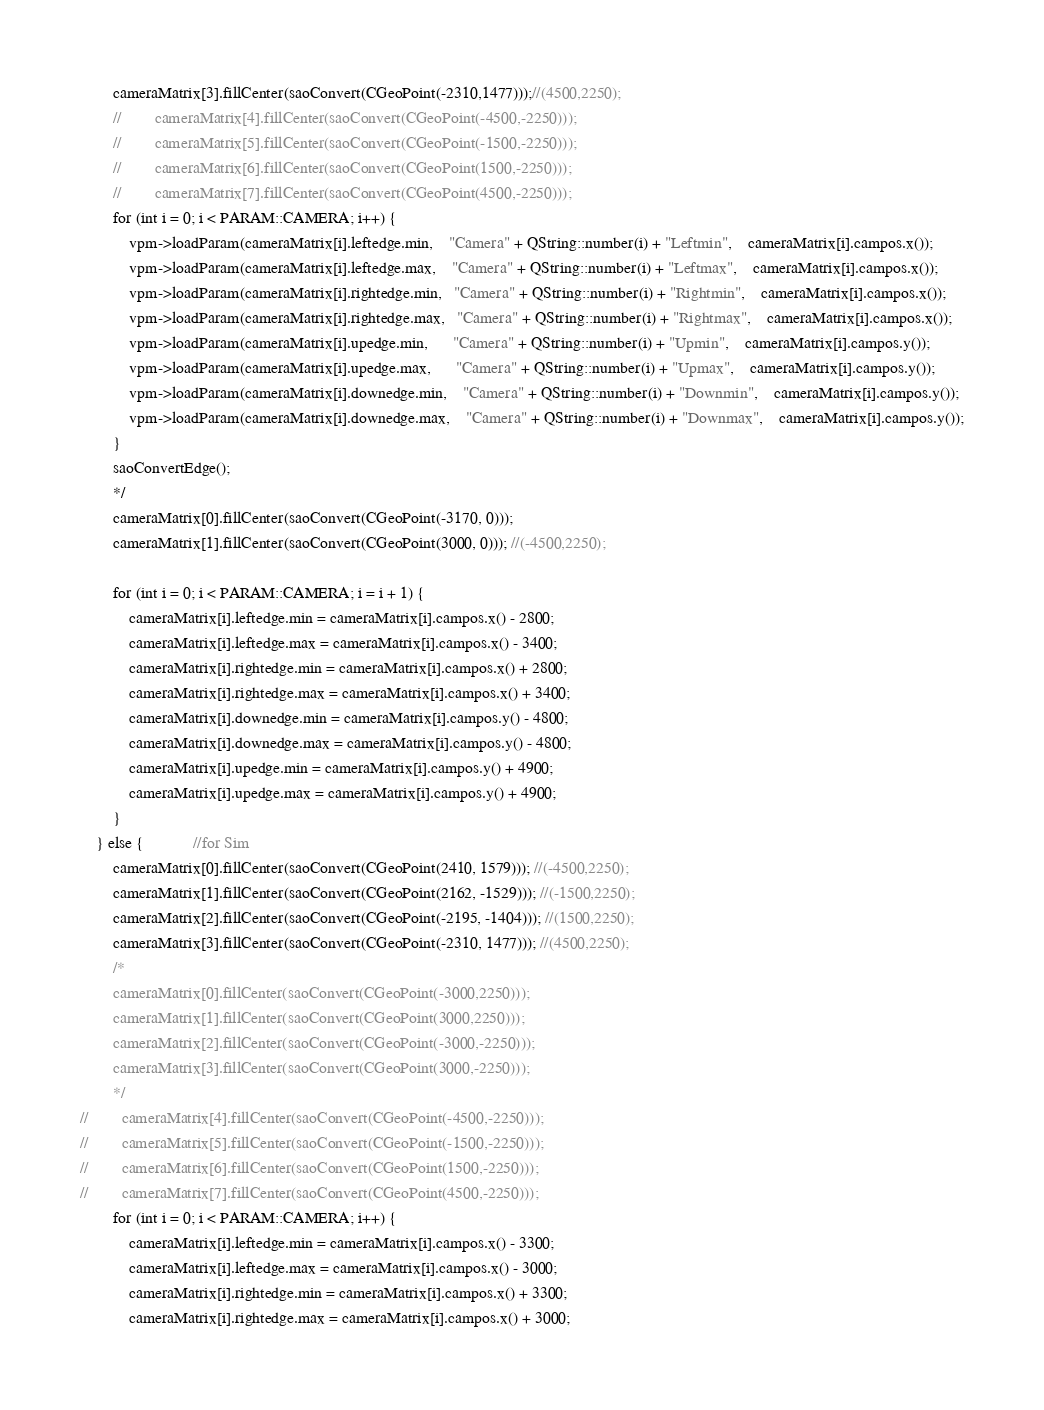Convert code to text. <code><loc_0><loc_0><loc_500><loc_500><_C++_>        cameraMatrix[3].fillCenter(saoConvert(CGeoPoint(-2310,1477)));//(4500,2250);
        //        cameraMatrix[4].fillCenter(saoConvert(CGeoPoint(-4500,-2250)));
        //        cameraMatrix[5].fillCenter(saoConvert(CGeoPoint(-1500,-2250)));
        //        cameraMatrix[6].fillCenter(saoConvert(CGeoPoint(1500,-2250)));
        //        cameraMatrix[7].fillCenter(saoConvert(CGeoPoint(4500,-2250)));
        for (int i = 0; i < PARAM::CAMERA; i++) {
            vpm->loadParam(cameraMatrix[i].leftedge.min,    "Camera" + QString::number(i) + "Leftmin",	cameraMatrix[i].campos.x());
            vpm->loadParam(cameraMatrix[i].leftedge.max,    "Camera" + QString::number(i) + "Leftmax",	cameraMatrix[i].campos.x());
            vpm->loadParam(cameraMatrix[i].rightedge.min,   "Camera" + QString::number(i) + "Rightmin",	cameraMatrix[i].campos.x());
            vpm->loadParam(cameraMatrix[i].rightedge.max,   "Camera" + QString::number(i) + "Rightmax",	cameraMatrix[i].campos.x());
            vpm->loadParam(cameraMatrix[i].upedge.min,      "Camera" + QString::number(i) + "Upmin",	cameraMatrix[i].campos.y());
            vpm->loadParam(cameraMatrix[i].upedge.max,      "Camera" + QString::number(i) + "Upmax",	cameraMatrix[i].campos.y());
            vpm->loadParam(cameraMatrix[i].downedge.min,    "Camera" + QString::number(i) + "Downmin",	cameraMatrix[i].campos.y());
            vpm->loadParam(cameraMatrix[i].downedge.max,    "Camera" + QString::number(i) + "Downmax",	cameraMatrix[i].campos.y());
        }
        saoConvertEdge();
        */
        cameraMatrix[0].fillCenter(saoConvert(CGeoPoint(-3170, 0)));
        cameraMatrix[1].fillCenter(saoConvert(CGeoPoint(3000, 0))); //(-4500,2250);

        for (int i = 0; i < PARAM::CAMERA; i = i + 1) {
            cameraMatrix[i].leftedge.min = cameraMatrix[i].campos.x() - 2800;
            cameraMatrix[i].leftedge.max = cameraMatrix[i].campos.x() - 3400;
            cameraMatrix[i].rightedge.min = cameraMatrix[i].campos.x() + 2800;
            cameraMatrix[i].rightedge.max = cameraMatrix[i].campos.x() + 3400;
            cameraMatrix[i].downedge.min = cameraMatrix[i].campos.y() - 4800;
            cameraMatrix[i].downedge.max = cameraMatrix[i].campos.y() - 4800;
            cameraMatrix[i].upedge.min = cameraMatrix[i].campos.y() + 4900;
            cameraMatrix[i].upedge.max = cameraMatrix[i].campos.y() + 4900;
        }
    } else {            //for Sim
        cameraMatrix[0].fillCenter(saoConvert(CGeoPoint(2410, 1579))); //(-4500,2250);
        cameraMatrix[1].fillCenter(saoConvert(CGeoPoint(2162, -1529))); //(-1500,2250);
        cameraMatrix[2].fillCenter(saoConvert(CGeoPoint(-2195, -1404))); //(1500,2250);
        cameraMatrix[3].fillCenter(saoConvert(CGeoPoint(-2310, 1477))); //(4500,2250);
        /*
        cameraMatrix[0].fillCenter(saoConvert(CGeoPoint(-3000,2250)));
        cameraMatrix[1].fillCenter(saoConvert(CGeoPoint(3000,2250)));
        cameraMatrix[2].fillCenter(saoConvert(CGeoPoint(-3000,-2250)));
        cameraMatrix[3].fillCenter(saoConvert(CGeoPoint(3000,-2250)));
        */
//        cameraMatrix[4].fillCenter(saoConvert(CGeoPoint(-4500,-2250)));
//        cameraMatrix[5].fillCenter(saoConvert(CGeoPoint(-1500,-2250)));
//        cameraMatrix[6].fillCenter(saoConvert(CGeoPoint(1500,-2250)));
//        cameraMatrix[7].fillCenter(saoConvert(CGeoPoint(4500,-2250)));
        for (int i = 0; i < PARAM::CAMERA; i++) {
            cameraMatrix[i].leftedge.min = cameraMatrix[i].campos.x() - 3300;
            cameraMatrix[i].leftedge.max = cameraMatrix[i].campos.x() - 3000;
            cameraMatrix[i].rightedge.min = cameraMatrix[i].campos.x() + 3300;
            cameraMatrix[i].rightedge.max = cameraMatrix[i].campos.x() + 3000;</code> 